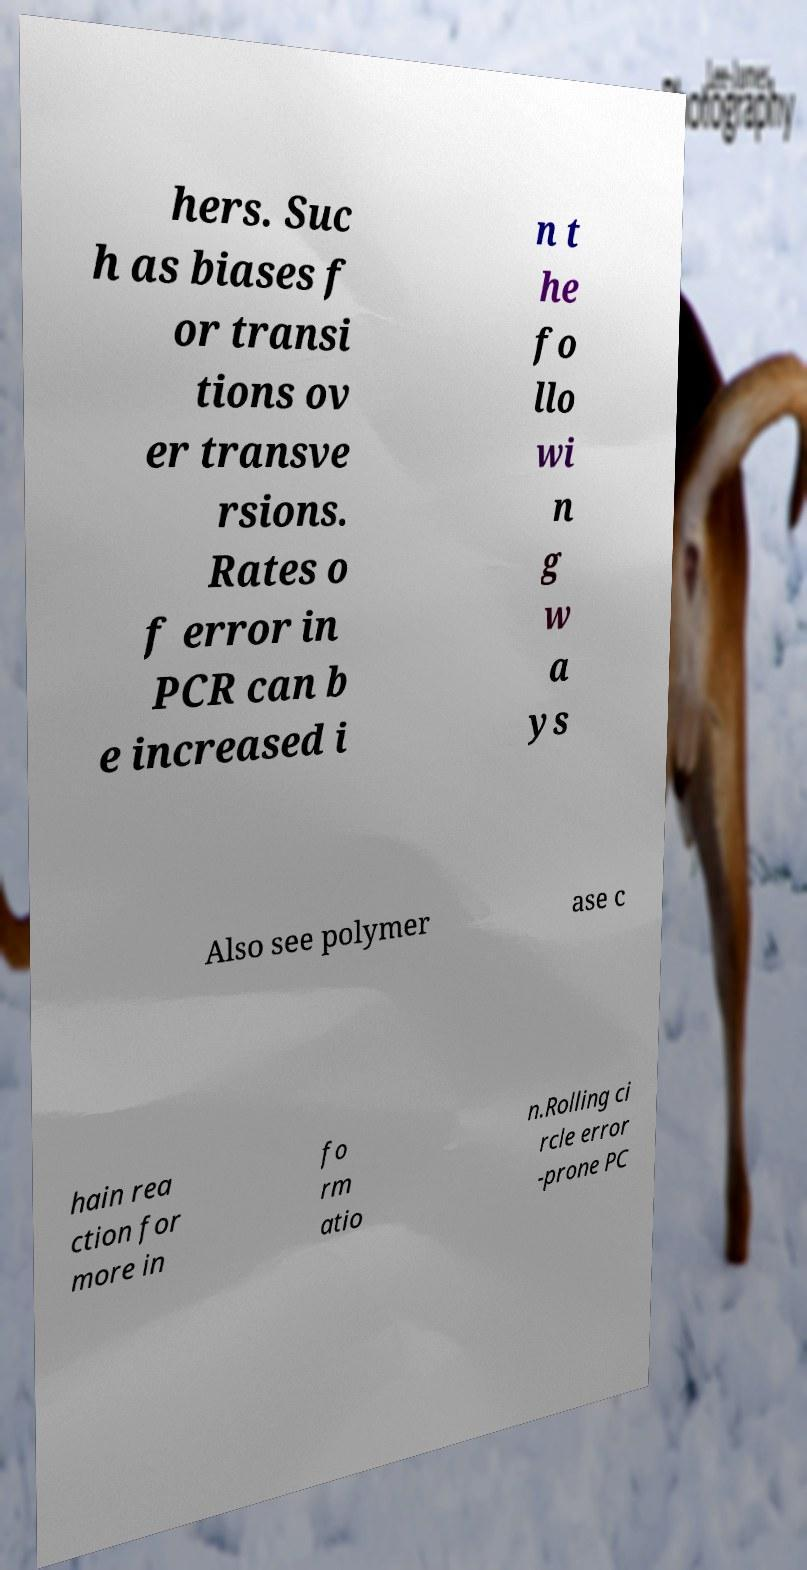For documentation purposes, I need the text within this image transcribed. Could you provide that? hers. Suc h as biases f or transi tions ov er transve rsions. Rates o f error in PCR can b e increased i n t he fo llo wi n g w a ys Also see polymer ase c hain rea ction for more in fo rm atio n.Rolling ci rcle error -prone PC 